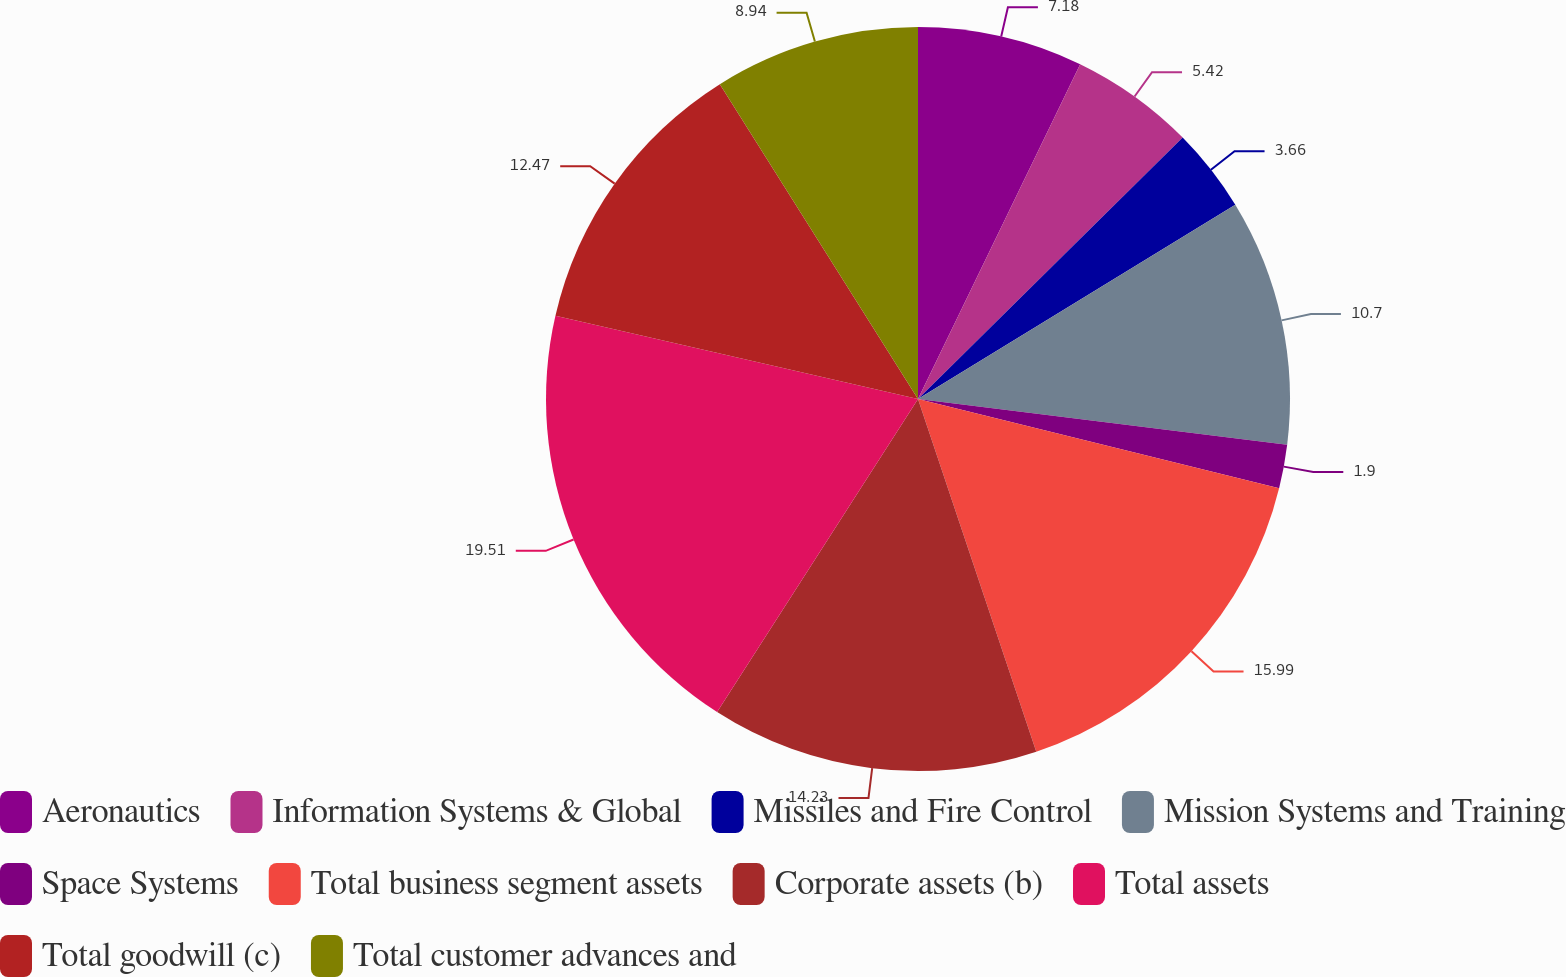<chart> <loc_0><loc_0><loc_500><loc_500><pie_chart><fcel>Aeronautics<fcel>Information Systems & Global<fcel>Missiles and Fire Control<fcel>Mission Systems and Training<fcel>Space Systems<fcel>Total business segment assets<fcel>Corporate assets (b)<fcel>Total assets<fcel>Total goodwill (c)<fcel>Total customer advances and<nl><fcel>7.18%<fcel>5.42%<fcel>3.66%<fcel>10.7%<fcel>1.9%<fcel>15.99%<fcel>14.23%<fcel>19.51%<fcel>12.47%<fcel>8.94%<nl></chart> 